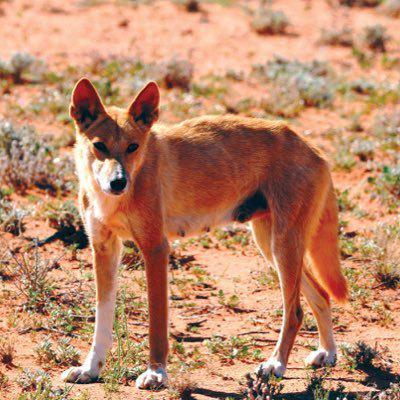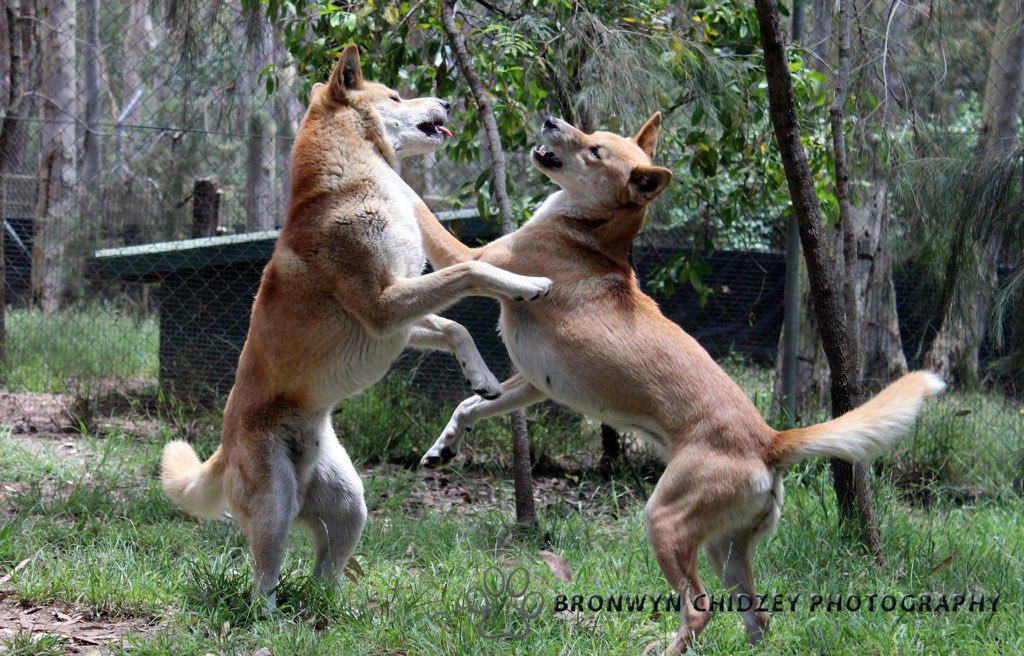The first image is the image on the left, the second image is the image on the right. Assess this claim about the two images: "Each image shows a single dingo standing on all fours, and the dingo on the right has its body turned leftward.". Correct or not? Answer yes or no. No. The first image is the image on the left, the second image is the image on the right. Examine the images to the left and right. Is the description "A dingo is surrounded by a grass and flowered ground cover" accurate? Answer yes or no. No. 